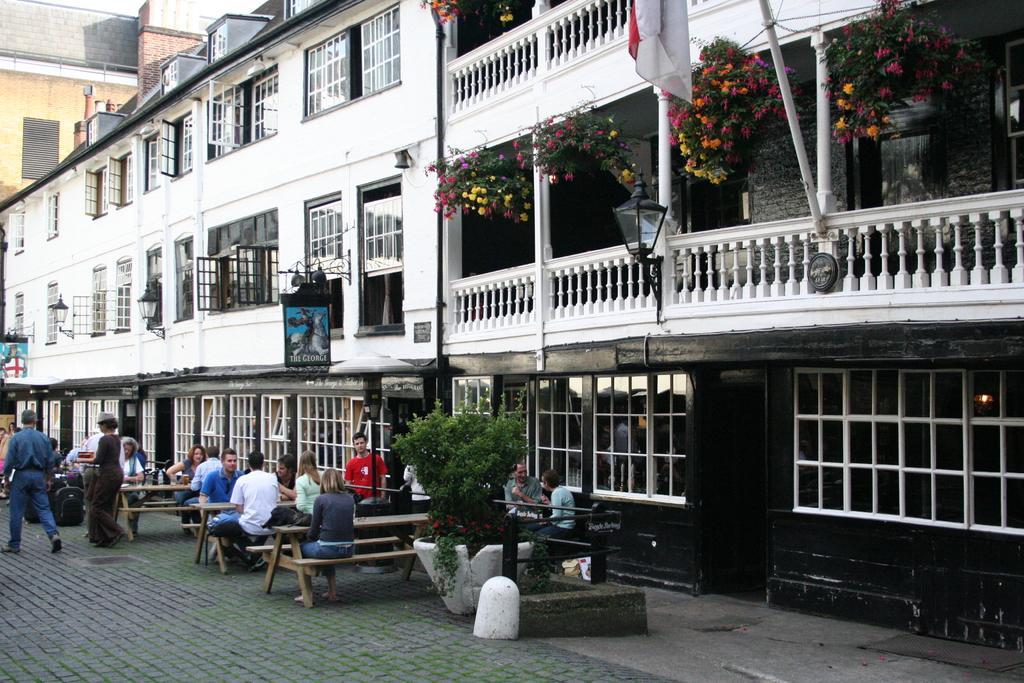Can you describe this image briefly? This image consists of building in the middle. There are some benches at the bottom. On that there are some persons sitting. There are plants in the middle. There are flowers to that plants. 